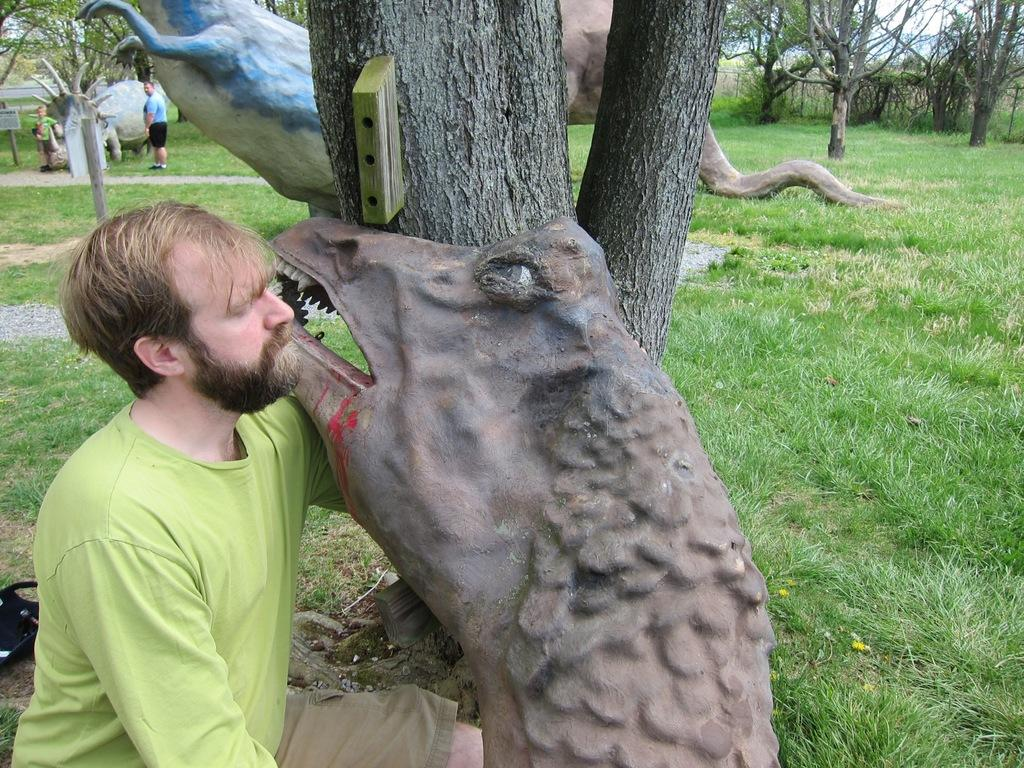What is the man in the image doing? The man is sitting beside a statue in the image. How many statues can be seen in the image? There are multiple statues in the image. What are the people in the image doing? There are people standing in the image. What is the ground covered with in the image? There is green grass on the ground in the image. What type of vegetation is visible in the image? There are trees visible in the image. What type of lettuce is growing on the statue in the image? There is no lettuce growing on the statue in the image; it is a statue and not a plant. What time is indicated by the clock in the image? There is no clock present in the image. --- Facts: 1. There is a car in the image. 2. The car is red. 3. The car has four wheels. 4. There are people inside the car. 5. The car is parked on the street. Absurd Topics: parrot, sand, umbrella Conversation: What type of vehicle is in the image? There is a car in the image. What color is the car? The car is red. How many wheels does the car have? The car has four wheels. Who is inside the car? There are people inside the car. Where is the car located in the image? The car is parked on the street. Reasoning: Let's think step by step in order to produce the conversation. We start by identifying the main subject in the image, which is the car. Then, we expand the conversation to include other details about the car, such as its color, number of wheels, and occupants. Finally, we describe the car's location in the image, which is parked on the street. Each question is designed to elicit a specific detail about the image that is known from the provided facts. Absurd Question/Answer: What type of parrot is sitting on the car's roof in the image? There is no parrot present on the car's roof in the image. What type of sand can be seen on the car's tires in the image? There is no sand present on the car's tires in the image. 